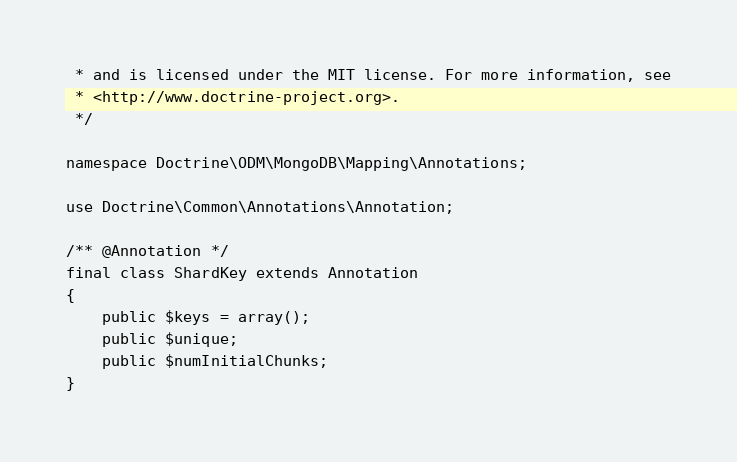Convert code to text. <code><loc_0><loc_0><loc_500><loc_500><_PHP_> * and is licensed under the MIT license. For more information, see
 * <http://www.doctrine-project.org>.
 */

namespace Doctrine\ODM\MongoDB\Mapping\Annotations;

use Doctrine\Common\Annotations\Annotation;

/** @Annotation */
final class ShardKey extends Annotation
{
    public $keys = array();
    public $unique;
    public $numInitialChunks;
}
</code> 